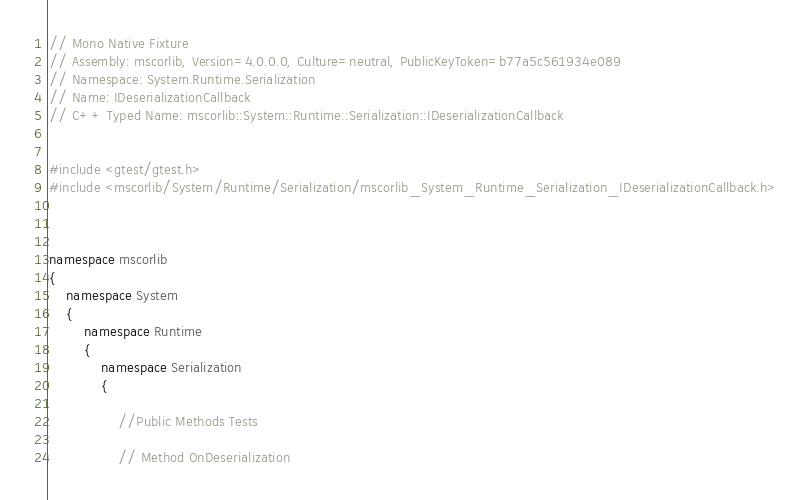Convert code to text. <code><loc_0><loc_0><loc_500><loc_500><_C++_>// Mono Native Fixture
// Assembly: mscorlib, Version=4.0.0.0, Culture=neutral, PublicKeyToken=b77a5c561934e089
// Namespace: System.Runtime.Serialization
// Name: IDeserializationCallback
// C++ Typed Name: mscorlib::System::Runtime::Serialization::IDeserializationCallback


#include <gtest/gtest.h>
#include <mscorlib/System/Runtime/Serialization/mscorlib_System_Runtime_Serialization_IDeserializationCallback.h>



namespace mscorlib
{
	namespace System
	{
		namespace Runtime
		{
			namespace Serialization
			{

				//Public Methods Tests
				
				// Method OnDeserialization</code> 